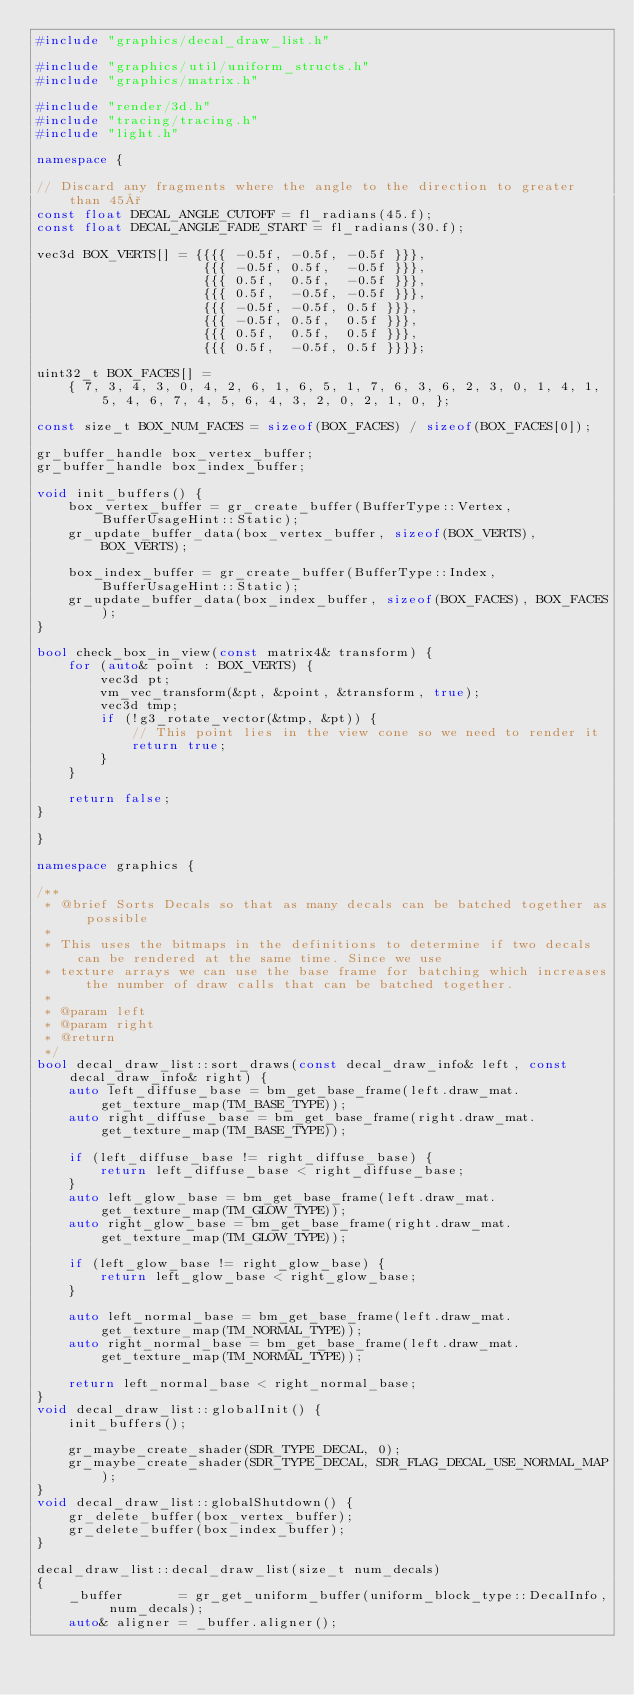<code> <loc_0><loc_0><loc_500><loc_500><_C++_>#include "graphics/decal_draw_list.h"

#include "graphics/util/uniform_structs.h"
#include "graphics/matrix.h"

#include "render/3d.h"
#include "tracing/tracing.h"
#include "light.h"

namespace {

// Discard any fragments where the angle to the direction to greater than 45°
const float DECAL_ANGLE_CUTOFF = fl_radians(45.f);
const float DECAL_ANGLE_FADE_START = fl_radians(30.f);

vec3d BOX_VERTS[] = {{{{ -0.5f, -0.5f, -0.5f }}},
					 {{{ -0.5f, 0.5f,  -0.5f }}},
					 {{{ 0.5f,  0.5f,  -0.5f }}},
					 {{{ 0.5f,  -0.5f, -0.5f }}},
					 {{{ -0.5f, -0.5f, 0.5f }}},
					 {{{ -0.5f, 0.5f,  0.5f }}},
					 {{{ 0.5f,  0.5f,  0.5f }}},
					 {{{ 0.5f,  -0.5f, 0.5f }}}};

uint32_t BOX_FACES[] =
	{ 7, 3, 4, 3, 0, 4, 2, 6, 1, 6, 5, 1, 7, 6, 3, 6, 2, 3, 0, 1, 4, 1, 5, 4, 6, 7, 4, 5, 6, 4, 3, 2, 0, 2, 1, 0, };

const size_t BOX_NUM_FACES = sizeof(BOX_FACES) / sizeof(BOX_FACES[0]);

gr_buffer_handle box_vertex_buffer;
gr_buffer_handle box_index_buffer;

void init_buffers() {
	box_vertex_buffer = gr_create_buffer(BufferType::Vertex, BufferUsageHint::Static);
	gr_update_buffer_data(box_vertex_buffer, sizeof(BOX_VERTS), BOX_VERTS);

	box_index_buffer = gr_create_buffer(BufferType::Index, BufferUsageHint::Static);
	gr_update_buffer_data(box_index_buffer, sizeof(BOX_FACES), BOX_FACES);
}

bool check_box_in_view(const matrix4& transform) {
	for (auto& point : BOX_VERTS) {
		vec3d pt;
		vm_vec_transform(&pt, &point, &transform, true);
		vec3d tmp;
		if (!g3_rotate_vector(&tmp, &pt)) {
			// This point lies in the view cone so we need to render it
			return true;
		}
	}

	return false;
}

}

namespace graphics {

/**
 * @brief Sorts Decals so that as many decals can be batched together as possible
 *
 * This uses the bitmaps in the definitions to determine if two decals can be rendered at the same time. Since we use
 * texture arrays we can use the base frame for batching which increases the number of draw calls that can be batched together.
 *
 * @param left
 * @param right
 * @return
 */
bool decal_draw_list::sort_draws(const decal_draw_info& left, const decal_draw_info& right) {
	auto left_diffuse_base = bm_get_base_frame(left.draw_mat.get_texture_map(TM_BASE_TYPE));
	auto right_diffuse_base = bm_get_base_frame(right.draw_mat.get_texture_map(TM_BASE_TYPE));

	if (left_diffuse_base != right_diffuse_base) {
		return left_diffuse_base < right_diffuse_base;
	}
	auto left_glow_base = bm_get_base_frame(left.draw_mat.get_texture_map(TM_GLOW_TYPE));
	auto right_glow_base = bm_get_base_frame(right.draw_mat.get_texture_map(TM_GLOW_TYPE));

	if (left_glow_base != right_glow_base) {
		return left_glow_base < right_glow_base;
	}

	auto left_normal_base = bm_get_base_frame(left.draw_mat.get_texture_map(TM_NORMAL_TYPE));
	auto right_normal_base = bm_get_base_frame(left.draw_mat.get_texture_map(TM_NORMAL_TYPE));

	return left_normal_base < right_normal_base;
}
void decal_draw_list::globalInit() {
	init_buffers();

	gr_maybe_create_shader(SDR_TYPE_DECAL, 0);
	gr_maybe_create_shader(SDR_TYPE_DECAL, SDR_FLAG_DECAL_USE_NORMAL_MAP);
}
void decal_draw_list::globalShutdown() {
	gr_delete_buffer(box_vertex_buffer);
	gr_delete_buffer(box_index_buffer);
}

decal_draw_list::decal_draw_list(size_t num_decals)
{
	_buffer       = gr_get_uniform_buffer(uniform_block_type::DecalInfo, num_decals);
	auto& aligner = _buffer.aligner();
</code> 